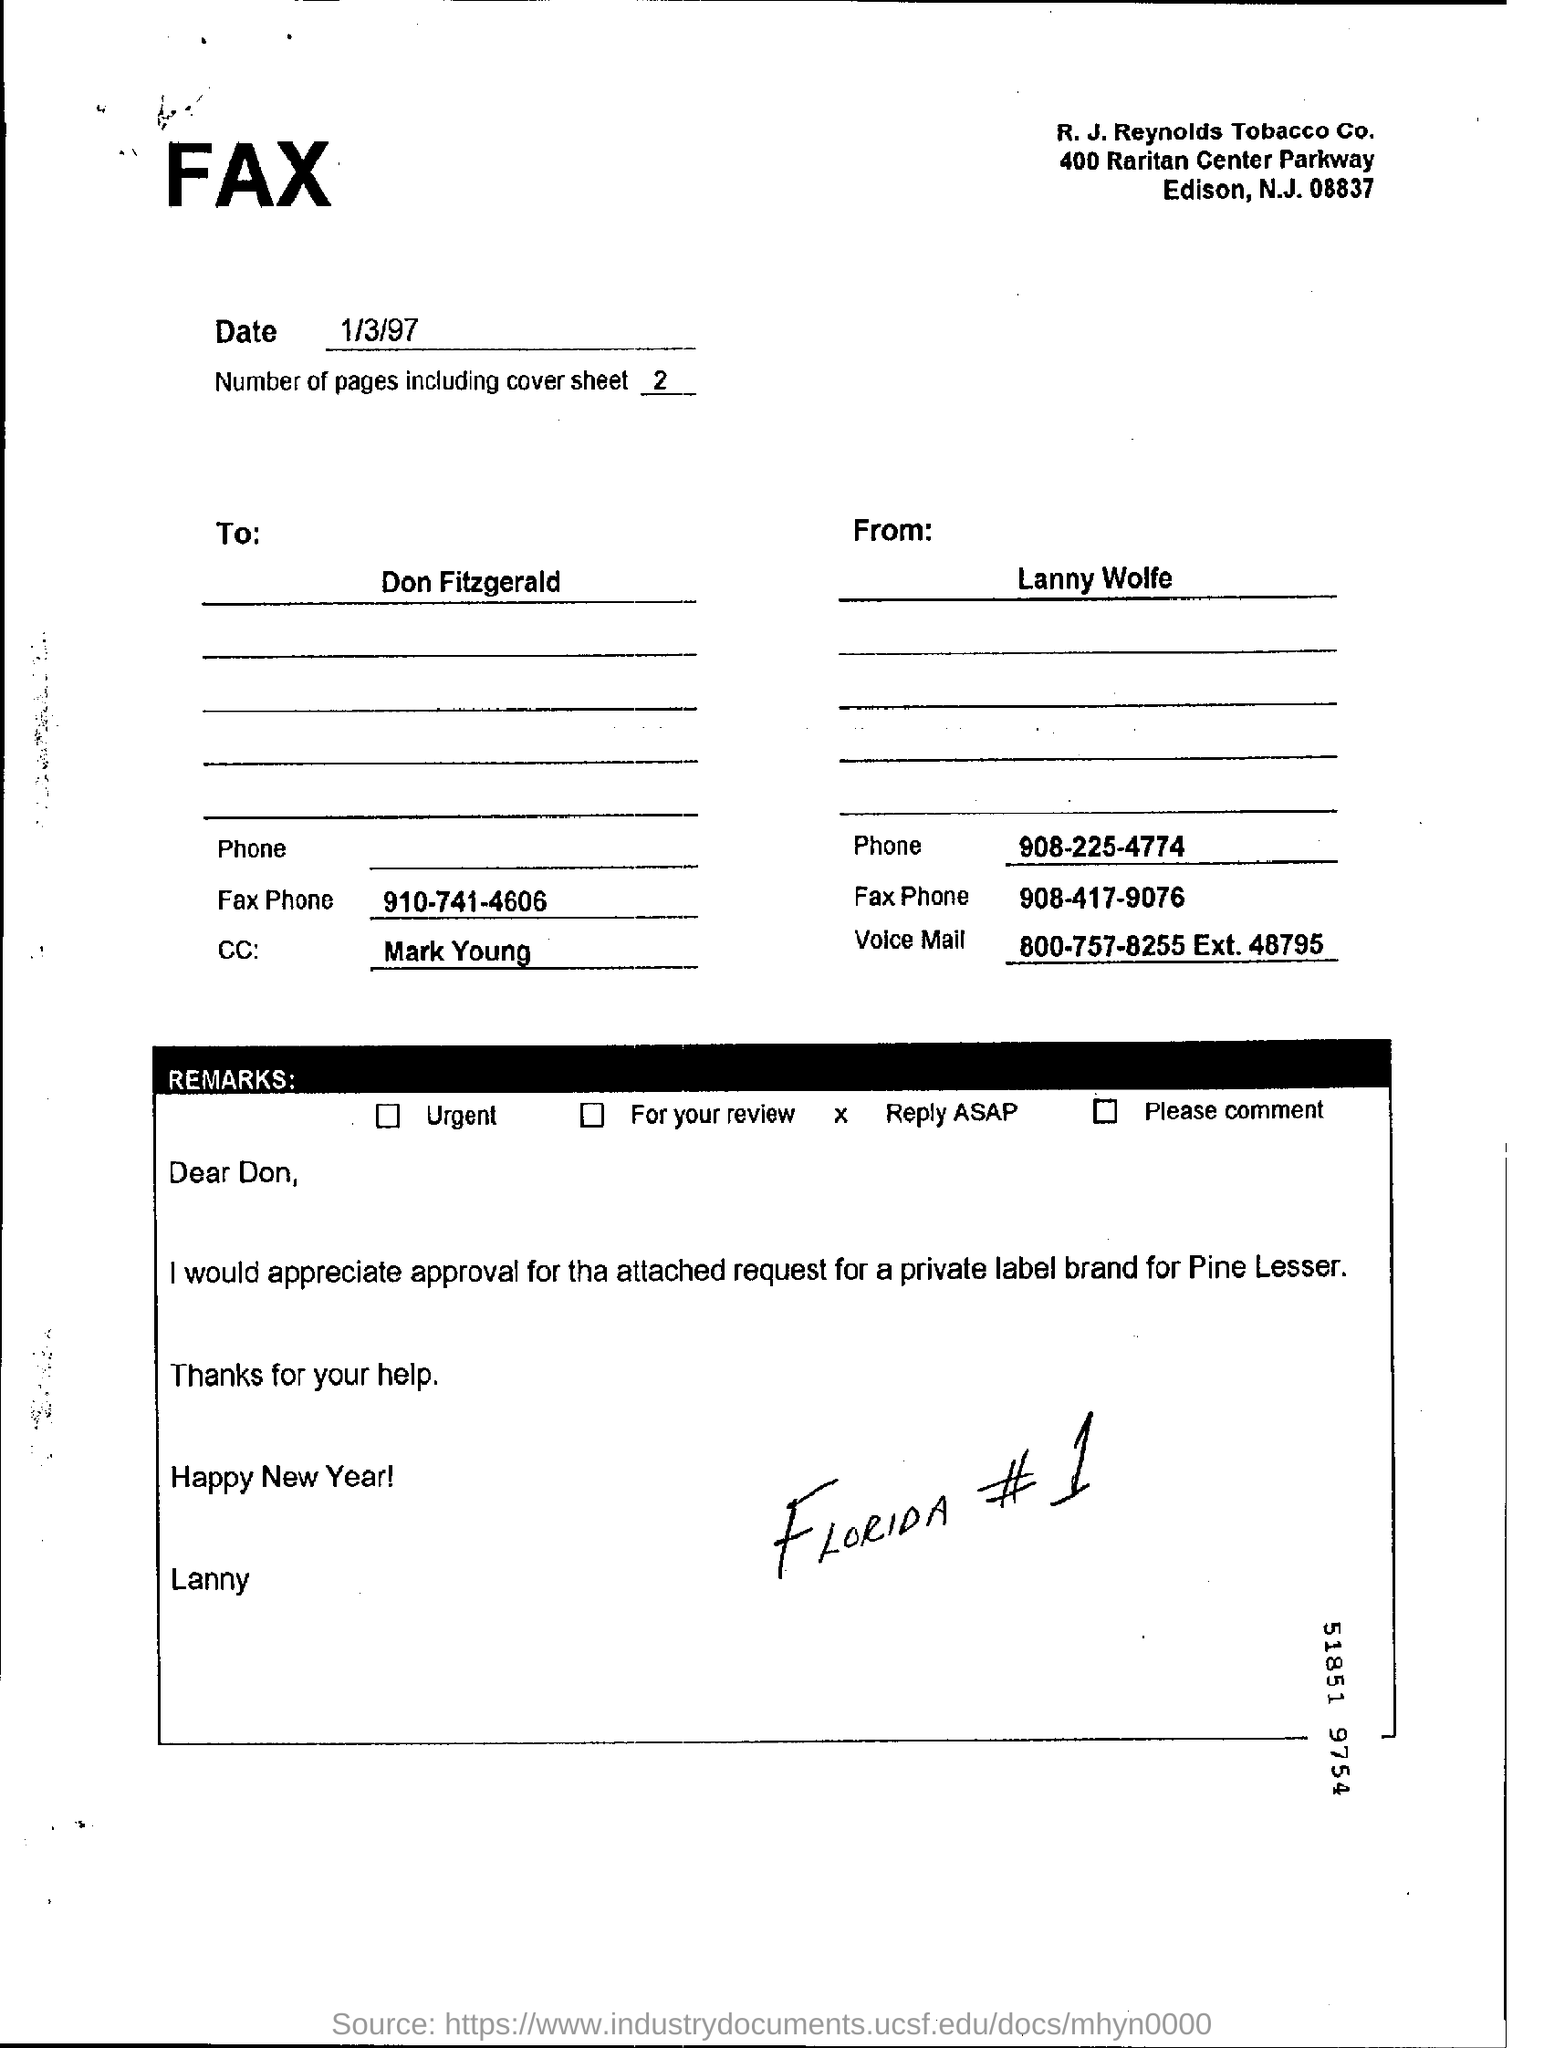Mention a couple of crucial points in this snapshot. The individual who is sending the fax is Lanny Wolfe. The fax is sent to Don Fitzgerald. The number of pages, including the cover sheet, is two. The date of the fax is January 3, 1997. 